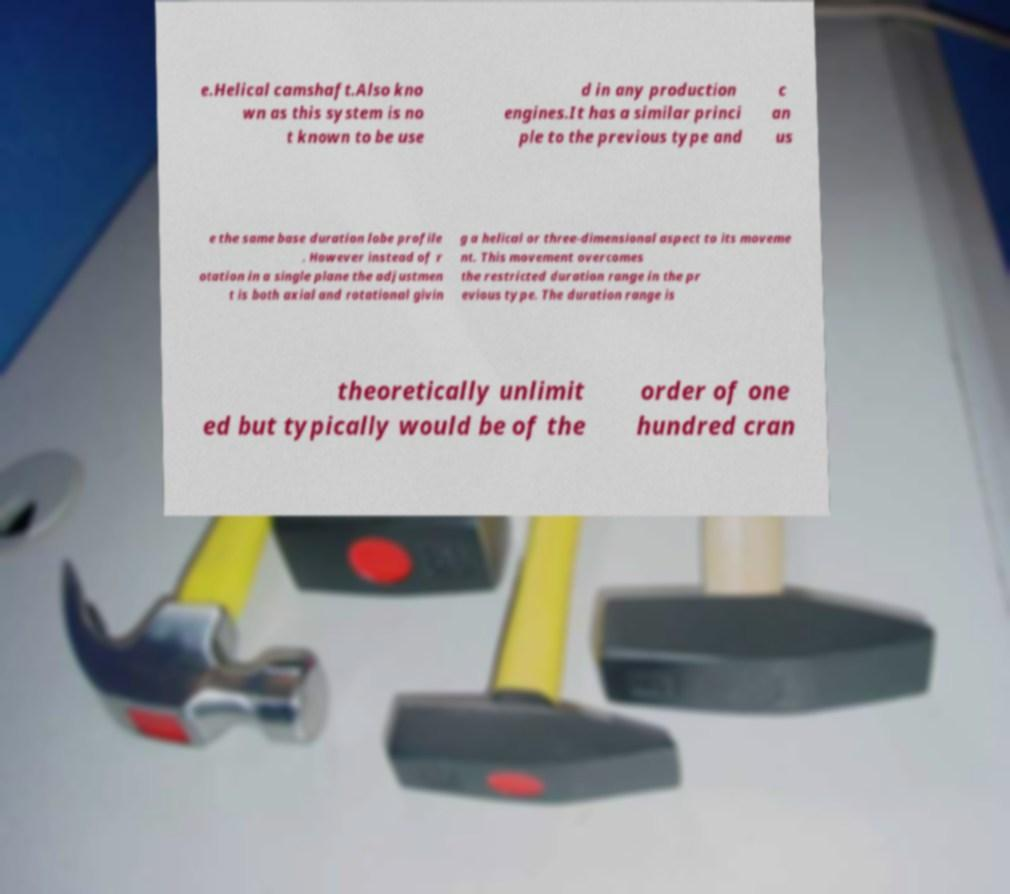Please identify and transcribe the text found in this image. e.Helical camshaft.Also kno wn as this system is no t known to be use d in any production engines.It has a similar princi ple to the previous type and c an us e the same base duration lobe profile . However instead of r otation in a single plane the adjustmen t is both axial and rotational givin g a helical or three-dimensional aspect to its moveme nt. This movement overcomes the restricted duration range in the pr evious type. The duration range is theoretically unlimit ed but typically would be of the order of one hundred cran 